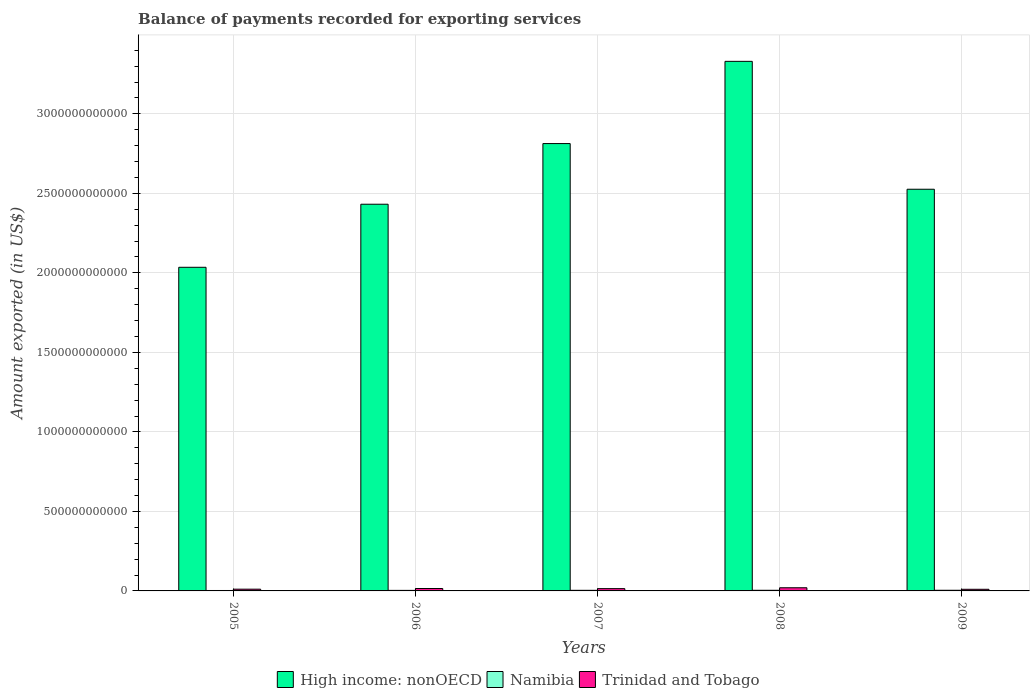How many different coloured bars are there?
Make the answer very short. 3. Are the number of bars per tick equal to the number of legend labels?
Your answer should be compact. Yes. In how many cases, is the number of bars for a given year not equal to the number of legend labels?
Your answer should be very brief. 0. What is the amount exported in High income: nonOECD in 2005?
Ensure brevity in your answer.  2.04e+12. Across all years, what is the maximum amount exported in Namibia?
Your response must be concise. 4.07e+09. Across all years, what is the minimum amount exported in High income: nonOECD?
Your response must be concise. 2.04e+12. In which year was the amount exported in Trinidad and Tobago maximum?
Give a very brief answer. 2008. What is the total amount exported in High income: nonOECD in the graph?
Keep it short and to the point. 1.31e+13. What is the difference between the amount exported in High income: nonOECD in 2005 and that in 2007?
Offer a terse response. -7.78e+11. What is the difference between the amount exported in Trinidad and Tobago in 2007 and the amount exported in Namibia in 2006?
Make the answer very short. 1.10e+1. What is the average amount exported in Namibia per year?
Your answer should be very brief. 3.60e+09. In the year 2006, what is the difference between the amount exported in Namibia and amount exported in Trinidad and Tobago?
Make the answer very short. -1.17e+1. In how many years, is the amount exported in Namibia greater than 1400000000000 US$?
Make the answer very short. 0. What is the ratio of the amount exported in Namibia in 2005 to that in 2006?
Make the answer very short. 0.79. What is the difference between the highest and the second highest amount exported in Namibia?
Offer a terse response. 4.59e+07. What is the difference between the highest and the lowest amount exported in Namibia?
Offer a terse response. 1.36e+09. Is the sum of the amount exported in Namibia in 2005 and 2008 greater than the maximum amount exported in High income: nonOECD across all years?
Offer a very short reply. No. What does the 1st bar from the left in 2005 represents?
Offer a terse response. High income: nonOECD. What does the 2nd bar from the right in 2006 represents?
Ensure brevity in your answer.  Namibia. Is it the case that in every year, the sum of the amount exported in Trinidad and Tobago and amount exported in High income: nonOECD is greater than the amount exported in Namibia?
Ensure brevity in your answer.  Yes. How many bars are there?
Keep it short and to the point. 15. How many years are there in the graph?
Make the answer very short. 5. What is the difference between two consecutive major ticks on the Y-axis?
Offer a terse response. 5.00e+11. Does the graph contain grids?
Provide a succinct answer. Yes. What is the title of the graph?
Make the answer very short. Balance of payments recorded for exporting services. What is the label or title of the X-axis?
Ensure brevity in your answer.  Years. What is the label or title of the Y-axis?
Make the answer very short. Amount exported (in US$). What is the Amount exported (in US$) in High income: nonOECD in 2005?
Keep it short and to the point. 2.04e+12. What is the Amount exported (in US$) of Namibia in 2005?
Give a very brief answer. 2.71e+09. What is the Amount exported (in US$) in Trinidad and Tobago in 2005?
Ensure brevity in your answer.  1.10e+1. What is the Amount exported (in US$) of High income: nonOECD in 2006?
Your response must be concise. 2.43e+12. What is the Amount exported (in US$) in Namibia in 2006?
Provide a succinct answer. 3.43e+09. What is the Amount exported (in US$) of Trinidad and Tobago in 2006?
Provide a succinct answer. 1.51e+1. What is the Amount exported (in US$) in High income: nonOECD in 2007?
Keep it short and to the point. 2.81e+12. What is the Amount exported (in US$) in Namibia in 2007?
Provide a short and direct response. 3.80e+09. What is the Amount exported (in US$) in Trinidad and Tobago in 2007?
Your answer should be very brief. 1.44e+1. What is the Amount exported (in US$) of High income: nonOECD in 2008?
Your answer should be very brief. 3.33e+12. What is the Amount exported (in US$) in Namibia in 2008?
Your answer should be very brief. 4.02e+09. What is the Amount exported (in US$) of Trinidad and Tobago in 2008?
Offer a very short reply. 1.99e+1. What is the Amount exported (in US$) of High income: nonOECD in 2009?
Ensure brevity in your answer.  2.53e+12. What is the Amount exported (in US$) in Namibia in 2009?
Make the answer very short. 4.07e+09. What is the Amount exported (in US$) of Trinidad and Tobago in 2009?
Offer a very short reply. 1.03e+1. Across all years, what is the maximum Amount exported (in US$) of High income: nonOECD?
Make the answer very short. 3.33e+12. Across all years, what is the maximum Amount exported (in US$) in Namibia?
Offer a terse response. 4.07e+09. Across all years, what is the maximum Amount exported (in US$) in Trinidad and Tobago?
Offer a very short reply. 1.99e+1. Across all years, what is the minimum Amount exported (in US$) of High income: nonOECD?
Ensure brevity in your answer.  2.04e+12. Across all years, what is the minimum Amount exported (in US$) in Namibia?
Provide a succinct answer. 2.71e+09. Across all years, what is the minimum Amount exported (in US$) of Trinidad and Tobago?
Ensure brevity in your answer.  1.03e+1. What is the total Amount exported (in US$) in High income: nonOECD in the graph?
Offer a very short reply. 1.31e+13. What is the total Amount exported (in US$) of Namibia in the graph?
Provide a short and direct response. 1.80e+1. What is the total Amount exported (in US$) of Trinidad and Tobago in the graph?
Your response must be concise. 7.06e+1. What is the difference between the Amount exported (in US$) of High income: nonOECD in 2005 and that in 2006?
Your response must be concise. -3.97e+11. What is the difference between the Amount exported (in US$) in Namibia in 2005 and that in 2006?
Ensure brevity in your answer.  -7.20e+08. What is the difference between the Amount exported (in US$) of Trinidad and Tobago in 2005 and that in 2006?
Your answer should be compact. -4.18e+09. What is the difference between the Amount exported (in US$) in High income: nonOECD in 2005 and that in 2007?
Make the answer very short. -7.78e+11. What is the difference between the Amount exported (in US$) in Namibia in 2005 and that in 2007?
Your response must be concise. -1.09e+09. What is the difference between the Amount exported (in US$) of Trinidad and Tobago in 2005 and that in 2007?
Ensure brevity in your answer.  -3.43e+09. What is the difference between the Amount exported (in US$) of High income: nonOECD in 2005 and that in 2008?
Provide a succinct answer. -1.30e+12. What is the difference between the Amount exported (in US$) in Namibia in 2005 and that in 2008?
Keep it short and to the point. -1.31e+09. What is the difference between the Amount exported (in US$) of Trinidad and Tobago in 2005 and that in 2008?
Keep it short and to the point. -8.90e+09. What is the difference between the Amount exported (in US$) in High income: nonOECD in 2005 and that in 2009?
Offer a very short reply. -4.91e+11. What is the difference between the Amount exported (in US$) of Namibia in 2005 and that in 2009?
Provide a short and direct response. -1.36e+09. What is the difference between the Amount exported (in US$) of Trinidad and Tobago in 2005 and that in 2009?
Your response must be concise. 6.96e+08. What is the difference between the Amount exported (in US$) of High income: nonOECD in 2006 and that in 2007?
Offer a very short reply. -3.82e+11. What is the difference between the Amount exported (in US$) of Namibia in 2006 and that in 2007?
Keep it short and to the point. -3.70e+08. What is the difference between the Amount exported (in US$) in Trinidad and Tobago in 2006 and that in 2007?
Provide a succinct answer. 7.53e+08. What is the difference between the Amount exported (in US$) in High income: nonOECD in 2006 and that in 2008?
Offer a terse response. -8.99e+11. What is the difference between the Amount exported (in US$) in Namibia in 2006 and that in 2008?
Provide a succinct answer. -5.91e+08. What is the difference between the Amount exported (in US$) of Trinidad and Tobago in 2006 and that in 2008?
Offer a very short reply. -4.73e+09. What is the difference between the Amount exported (in US$) in High income: nonOECD in 2006 and that in 2009?
Provide a short and direct response. -9.42e+1. What is the difference between the Amount exported (in US$) of Namibia in 2006 and that in 2009?
Provide a succinct answer. -6.37e+08. What is the difference between the Amount exported (in US$) of Trinidad and Tobago in 2006 and that in 2009?
Your answer should be very brief. 4.87e+09. What is the difference between the Amount exported (in US$) of High income: nonOECD in 2007 and that in 2008?
Your answer should be compact. -5.17e+11. What is the difference between the Amount exported (in US$) of Namibia in 2007 and that in 2008?
Offer a terse response. -2.21e+08. What is the difference between the Amount exported (in US$) in Trinidad and Tobago in 2007 and that in 2008?
Make the answer very short. -5.48e+09. What is the difference between the Amount exported (in US$) of High income: nonOECD in 2007 and that in 2009?
Provide a succinct answer. 2.87e+11. What is the difference between the Amount exported (in US$) of Namibia in 2007 and that in 2009?
Offer a very short reply. -2.67e+08. What is the difference between the Amount exported (in US$) in Trinidad and Tobago in 2007 and that in 2009?
Make the answer very short. 4.12e+09. What is the difference between the Amount exported (in US$) in High income: nonOECD in 2008 and that in 2009?
Give a very brief answer. 8.04e+11. What is the difference between the Amount exported (in US$) in Namibia in 2008 and that in 2009?
Make the answer very short. -4.59e+07. What is the difference between the Amount exported (in US$) of Trinidad and Tobago in 2008 and that in 2009?
Give a very brief answer. 9.60e+09. What is the difference between the Amount exported (in US$) in High income: nonOECD in 2005 and the Amount exported (in US$) in Namibia in 2006?
Your response must be concise. 2.03e+12. What is the difference between the Amount exported (in US$) of High income: nonOECD in 2005 and the Amount exported (in US$) of Trinidad and Tobago in 2006?
Offer a terse response. 2.02e+12. What is the difference between the Amount exported (in US$) of Namibia in 2005 and the Amount exported (in US$) of Trinidad and Tobago in 2006?
Your response must be concise. -1.24e+1. What is the difference between the Amount exported (in US$) of High income: nonOECD in 2005 and the Amount exported (in US$) of Namibia in 2007?
Ensure brevity in your answer.  2.03e+12. What is the difference between the Amount exported (in US$) of High income: nonOECD in 2005 and the Amount exported (in US$) of Trinidad and Tobago in 2007?
Your answer should be compact. 2.02e+12. What is the difference between the Amount exported (in US$) in Namibia in 2005 and the Amount exported (in US$) in Trinidad and Tobago in 2007?
Offer a terse response. -1.17e+1. What is the difference between the Amount exported (in US$) of High income: nonOECD in 2005 and the Amount exported (in US$) of Namibia in 2008?
Your response must be concise. 2.03e+12. What is the difference between the Amount exported (in US$) in High income: nonOECD in 2005 and the Amount exported (in US$) in Trinidad and Tobago in 2008?
Give a very brief answer. 2.02e+12. What is the difference between the Amount exported (in US$) of Namibia in 2005 and the Amount exported (in US$) of Trinidad and Tobago in 2008?
Ensure brevity in your answer.  -1.72e+1. What is the difference between the Amount exported (in US$) in High income: nonOECD in 2005 and the Amount exported (in US$) in Namibia in 2009?
Offer a very short reply. 2.03e+12. What is the difference between the Amount exported (in US$) in High income: nonOECD in 2005 and the Amount exported (in US$) in Trinidad and Tobago in 2009?
Provide a short and direct response. 2.02e+12. What is the difference between the Amount exported (in US$) of Namibia in 2005 and the Amount exported (in US$) of Trinidad and Tobago in 2009?
Provide a succinct answer. -7.56e+09. What is the difference between the Amount exported (in US$) in High income: nonOECD in 2006 and the Amount exported (in US$) in Namibia in 2007?
Offer a terse response. 2.43e+12. What is the difference between the Amount exported (in US$) of High income: nonOECD in 2006 and the Amount exported (in US$) of Trinidad and Tobago in 2007?
Keep it short and to the point. 2.42e+12. What is the difference between the Amount exported (in US$) in Namibia in 2006 and the Amount exported (in US$) in Trinidad and Tobago in 2007?
Give a very brief answer. -1.10e+1. What is the difference between the Amount exported (in US$) of High income: nonOECD in 2006 and the Amount exported (in US$) of Namibia in 2008?
Offer a very short reply. 2.43e+12. What is the difference between the Amount exported (in US$) of High income: nonOECD in 2006 and the Amount exported (in US$) of Trinidad and Tobago in 2008?
Ensure brevity in your answer.  2.41e+12. What is the difference between the Amount exported (in US$) in Namibia in 2006 and the Amount exported (in US$) in Trinidad and Tobago in 2008?
Ensure brevity in your answer.  -1.64e+1. What is the difference between the Amount exported (in US$) in High income: nonOECD in 2006 and the Amount exported (in US$) in Namibia in 2009?
Keep it short and to the point. 2.43e+12. What is the difference between the Amount exported (in US$) of High income: nonOECD in 2006 and the Amount exported (in US$) of Trinidad and Tobago in 2009?
Give a very brief answer. 2.42e+12. What is the difference between the Amount exported (in US$) of Namibia in 2006 and the Amount exported (in US$) of Trinidad and Tobago in 2009?
Offer a very short reply. -6.84e+09. What is the difference between the Amount exported (in US$) in High income: nonOECD in 2007 and the Amount exported (in US$) in Namibia in 2008?
Your response must be concise. 2.81e+12. What is the difference between the Amount exported (in US$) of High income: nonOECD in 2007 and the Amount exported (in US$) of Trinidad and Tobago in 2008?
Your answer should be very brief. 2.79e+12. What is the difference between the Amount exported (in US$) in Namibia in 2007 and the Amount exported (in US$) in Trinidad and Tobago in 2008?
Provide a succinct answer. -1.61e+1. What is the difference between the Amount exported (in US$) of High income: nonOECD in 2007 and the Amount exported (in US$) of Namibia in 2009?
Provide a succinct answer. 2.81e+12. What is the difference between the Amount exported (in US$) in High income: nonOECD in 2007 and the Amount exported (in US$) in Trinidad and Tobago in 2009?
Give a very brief answer. 2.80e+12. What is the difference between the Amount exported (in US$) of Namibia in 2007 and the Amount exported (in US$) of Trinidad and Tobago in 2009?
Provide a short and direct response. -6.47e+09. What is the difference between the Amount exported (in US$) in High income: nonOECD in 2008 and the Amount exported (in US$) in Namibia in 2009?
Provide a succinct answer. 3.33e+12. What is the difference between the Amount exported (in US$) of High income: nonOECD in 2008 and the Amount exported (in US$) of Trinidad and Tobago in 2009?
Offer a terse response. 3.32e+12. What is the difference between the Amount exported (in US$) in Namibia in 2008 and the Amount exported (in US$) in Trinidad and Tobago in 2009?
Your answer should be compact. -6.25e+09. What is the average Amount exported (in US$) of High income: nonOECD per year?
Make the answer very short. 2.63e+12. What is the average Amount exported (in US$) of Namibia per year?
Make the answer very short. 3.60e+09. What is the average Amount exported (in US$) of Trinidad and Tobago per year?
Provide a succinct answer. 1.41e+1. In the year 2005, what is the difference between the Amount exported (in US$) in High income: nonOECD and Amount exported (in US$) in Namibia?
Offer a terse response. 2.03e+12. In the year 2005, what is the difference between the Amount exported (in US$) of High income: nonOECD and Amount exported (in US$) of Trinidad and Tobago?
Your response must be concise. 2.02e+12. In the year 2005, what is the difference between the Amount exported (in US$) of Namibia and Amount exported (in US$) of Trinidad and Tobago?
Ensure brevity in your answer.  -8.25e+09. In the year 2006, what is the difference between the Amount exported (in US$) of High income: nonOECD and Amount exported (in US$) of Namibia?
Make the answer very short. 2.43e+12. In the year 2006, what is the difference between the Amount exported (in US$) of High income: nonOECD and Amount exported (in US$) of Trinidad and Tobago?
Provide a short and direct response. 2.42e+12. In the year 2006, what is the difference between the Amount exported (in US$) in Namibia and Amount exported (in US$) in Trinidad and Tobago?
Make the answer very short. -1.17e+1. In the year 2007, what is the difference between the Amount exported (in US$) of High income: nonOECD and Amount exported (in US$) of Namibia?
Keep it short and to the point. 2.81e+12. In the year 2007, what is the difference between the Amount exported (in US$) in High income: nonOECD and Amount exported (in US$) in Trinidad and Tobago?
Your answer should be very brief. 2.80e+12. In the year 2007, what is the difference between the Amount exported (in US$) of Namibia and Amount exported (in US$) of Trinidad and Tobago?
Ensure brevity in your answer.  -1.06e+1. In the year 2008, what is the difference between the Amount exported (in US$) in High income: nonOECD and Amount exported (in US$) in Namibia?
Provide a succinct answer. 3.33e+12. In the year 2008, what is the difference between the Amount exported (in US$) in High income: nonOECD and Amount exported (in US$) in Trinidad and Tobago?
Ensure brevity in your answer.  3.31e+12. In the year 2008, what is the difference between the Amount exported (in US$) of Namibia and Amount exported (in US$) of Trinidad and Tobago?
Your answer should be very brief. -1.58e+1. In the year 2009, what is the difference between the Amount exported (in US$) of High income: nonOECD and Amount exported (in US$) of Namibia?
Your answer should be compact. 2.52e+12. In the year 2009, what is the difference between the Amount exported (in US$) in High income: nonOECD and Amount exported (in US$) in Trinidad and Tobago?
Provide a succinct answer. 2.52e+12. In the year 2009, what is the difference between the Amount exported (in US$) in Namibia and Amount exported (in US$) in Trinidad and Tobago?
Offer a very short reply. -6.20e+09. What is the ratio of the Amount exported (in US$) of High income: nonOECD in 2005 to that in 2006?
Your answer should be compact. 0.84. What is the ratio of the Amount exported (in US$) of Namibia in 2005 to that in 2006?
Give a very brief answer. 0.79. What is the ratio of the Amount exported (in US$) in Trinidad and Tobago in 2005 to that in 2006?
Provide a succinct answer. 0.72. What is the ratio of the Amount exported (in US$) of High income: nonOECD in 2005 to that in 2007?
Provide a succinct answer. 0.72. What is the ratio of the Amount exported (in US$) in Namibia in 2005 to that in 2007?
Your answer should be compact. 0.71. What is the ratio of the Amount exported (in US$) in Trinidad and Tobago in 2005 to that in 2007?
Offer a very short reply. 0.76. What is the ratio of the Amount exported (in US$) of High income: nonOECD in 2005 to that in 2008?
Offer a very short reply. 0.61. What is the ratio of the Amount exported (in US$) of Namibia in 2005 to that in 2008?
Your answer should be very brief. 0.67. What is the ratio of the Amount exported (in US$) in Trinidad and Tobago in 2005 to that in 2008?
Provide a succinct answer. 0.55. What is the ratio of the Amount exported (in US$) in High income: nonOECD in 2005 to that in 2009?
Make the answer very short. 0.81. What is the ratio of the Amount exported (in US$) of Namibia in 2005 to that in 2009?
Your answer should be very brief. 0.67. What is the ratio of the Amount exported (in US$) in Trinidad and Tobago in 2005 to that in 2009?
Your answer should be compact. 1.07. What is the ratio of the Amount exported (in US$) of High income: nonOECD in 2006 to that in 2007?
Provide a short and direct response. 0.86. What is the ratio of the Amount exported (in US$) in Namibia in 2006 to that in 2007?
Your answer should be compact. 0.9. What is the ratio of the Amount exported (in US$) of Trinidad and Tobago in 2006 to that in 2007?
Make the answer very short. 1.05. What is the ratio of the Amount exported (in US$) of High income: nonOECD in 2006 to that in 2008?
Offer a terse response. 0.73. What is the ratio of the Amount exported (in US$) of Namibia in 2006 to that in 2008?
Keep it short and to the point. 0.85. What is the ratio of the Amount exported (in US$) of Trinidad and Tobago in 2006 to that in 2008?
Provide a short and direct response. 0.76. What is the ratio of the Amount exported (in US$) of High income: nonOECD in 2006 to that in 2009?
Make the answer very short. 0.96. What is the ratio of the Amount exported (in US$) of Namibia in 2006 to that in 2009?
Your answer should be compact. 0.84. What is the ratio of the Amount exported (in US$) of Trinidad and Tobago in 2006 to that in 2009?
Give a very brief answer. 1.47. What is the ratio of the Amount exported (in US$) in High income: nonOECD in 2007 to that in 2008?
Provide a succinct answer. 0.84. What is the ratio of the Amount exported (in US$) of Namibia in 2007 to that in 2008?
Provide a short and direct response. 0.94. What is the ratio of the Amount exported (in US$) in Trinidad and Tobago in 2007 to that in 2008?
Keep it short and to the point. 0.72. What is the ratio of the Amount exported (in US$) of High income: nonOECD in 2007 to that in 2009?
Provide a succinct answer. 1.11. What is the ratio of the Amount exported (in US$) of Namibia in 2007 to that in 2009?
Offer a terse response. 0.93. What is the ratio of the Amount exported (in US$) of Trinidad and Tobago in 2007 to that in 2009?
Your answer should be compact. 1.4. What is the ratio of the Amount exported (in US$) in High income: nonOECD in 2008 to that in 2009?
Give a very brief answer. 1.32. What is the ratio of the Amount exported (in US$) in Namibia in 2008 to that in 2009?
Your answer should be compact. 0.99. What is the ratio of the Amount exported (in US$) in Trinidad and Tobago in 2008 to that in 2009?
Your answer should be compact. 1.94. What is the difference between the highest and the second highest Amount exported (in US$) of High income: nonOECD?
Offer a very short reply. 5.17e+11. What is the difference between the highest and the second highest Amount exported (in US$) in Namibia?
Your answer should be compact. 4.59e+07. What is the difference between the highest and the second highest Amount exported (in US$) in Trinidad and Tobago?
Offer a terse response. 4.73e+09. What is the difference between the highest and the lowest Amount exported (in US$) in High income: nonOECD?
Ensure brevity in your answer.  1.30e+12. What is the difference between the highest and the lowest Amount exported (in US$) of Namibia?
Your answer should be very brief. 1.36e+09. What is the difference between the highest and the lowest Amount exported (in US$) in Trinidad and Tobago?
Provide a short and direct response. 9.60e+09. 